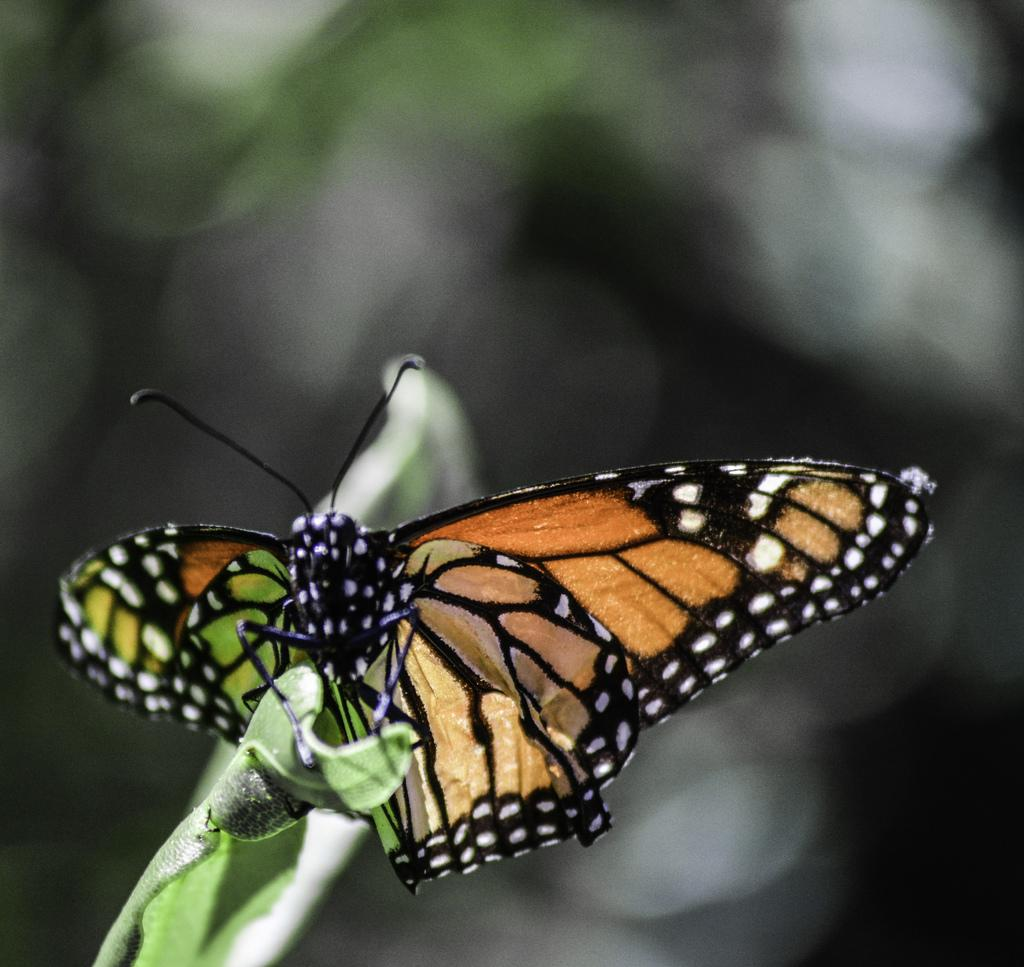What is the main subject of the image? There is a butterfly in the image. Where is the butterfly located? The butterfly is on a leaf. Can you describe the background of the image? The background of the image is blurred. What is the girl's face expression in the image? There is no girl present in the image, only a butterfly on a leaf. 